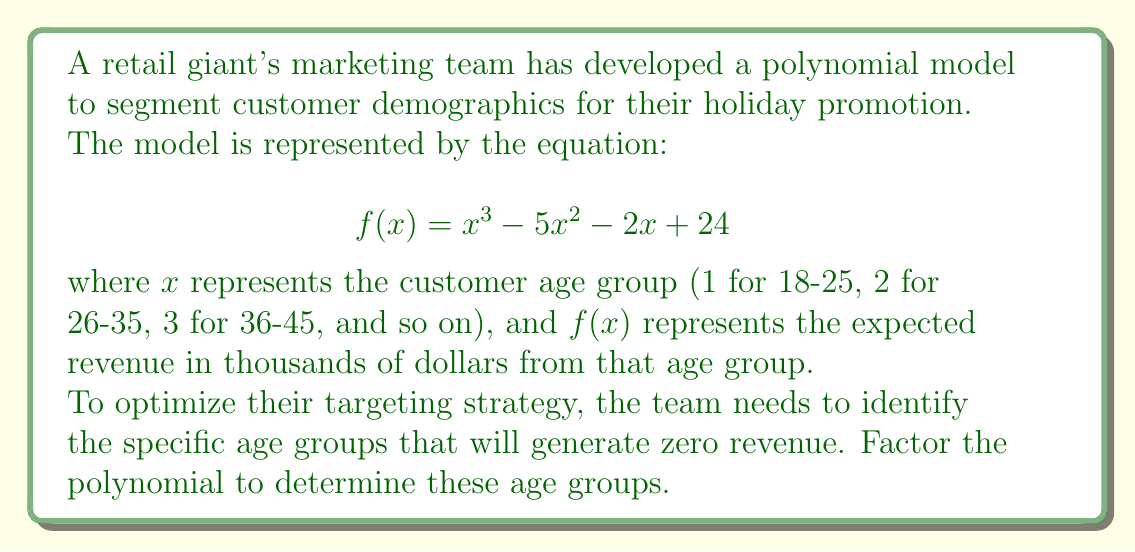Give your solution to this math problem. Let's approach this step-by-step:

1) We need to factor the polynomial $f(x) = x^3 - 5x^2 - 2x + 24$

2) First, let's check if there are any rational roots using the rational root theorem. The possible rational roots are the factors of the constant term (24): ±1, ±2, ±3, ±4, ±6, ±8, ±12, ±24

3) Testing these values, we find that $f(4) = 0$. So $(x-4)$ is a factor.

4) Divide the polynomial by $(x-4)$:

   $$ \frac{x^3 - 5x^2 - 2x + 24}{x - 4} = x^2 - x - 6 $$

5) Now we need to factor $x^2 - x - 6$

6) This is a quadratic equation. We can factor it as:

   $$ x^2 - x - 6 = (x-3)(x+2) $$

7) Therefore, the complete factorization is:

   $$ f(x) = (x-4)(x-3)(x+2) $$

8) The roots of this polynomial are $x = 4$, $x = 3$, and $x = -2$

9) However, since $x$ represents age groups starting from 1, we can disregard the negative solution.

10) Therefore, the age groups that will generate zero revenue are represented by $x = 3$ and $x = 4$, corresponding to age groups 36-45 and 46-55.
Answer: Age groups 36-45 and 46-55 